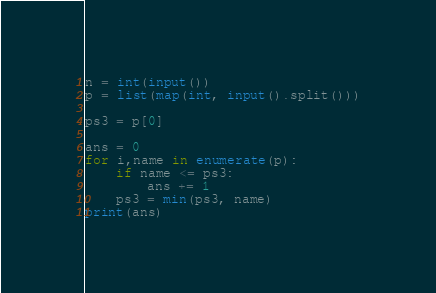Convert code to text. <code><loc_0><loc_0><loc_500><loc_500><_Python_>n = int(input())
p = list(map(int, input().split()))

ps3 = p[0]

ans = 0
for i,name in enumerate(p):
    if name <= ps3:
        ans += 1
    ps3 = min(ps3, name)
print(ans)</code> 